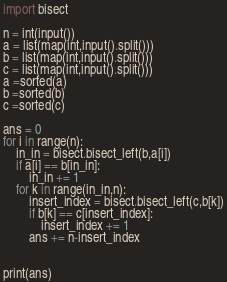Convert code to text. <code><loc_0><loc_0><loc_500><loc_500><_Python_>import bisect

n = int(input())
a = list(map(int,input().split()))
b = list(map(int,input().split()))
c = list(map(int,input().split()))
a =sorted(a)
b =sorted(b)
c =sorted(c)

ans = 0
for i in range(n):
    in_in = bisect.bisect_left(b,a[i])
    if a[i] == b[in_in]:
        in_in += 1
    for k in range(in_in,n):
        insert_index = bisect.bisect_left(c,b[k])
        if b[k] == c[insert_index]:
            insert_index += 1
        ans += n-insert_index


print(ans)
</code> 